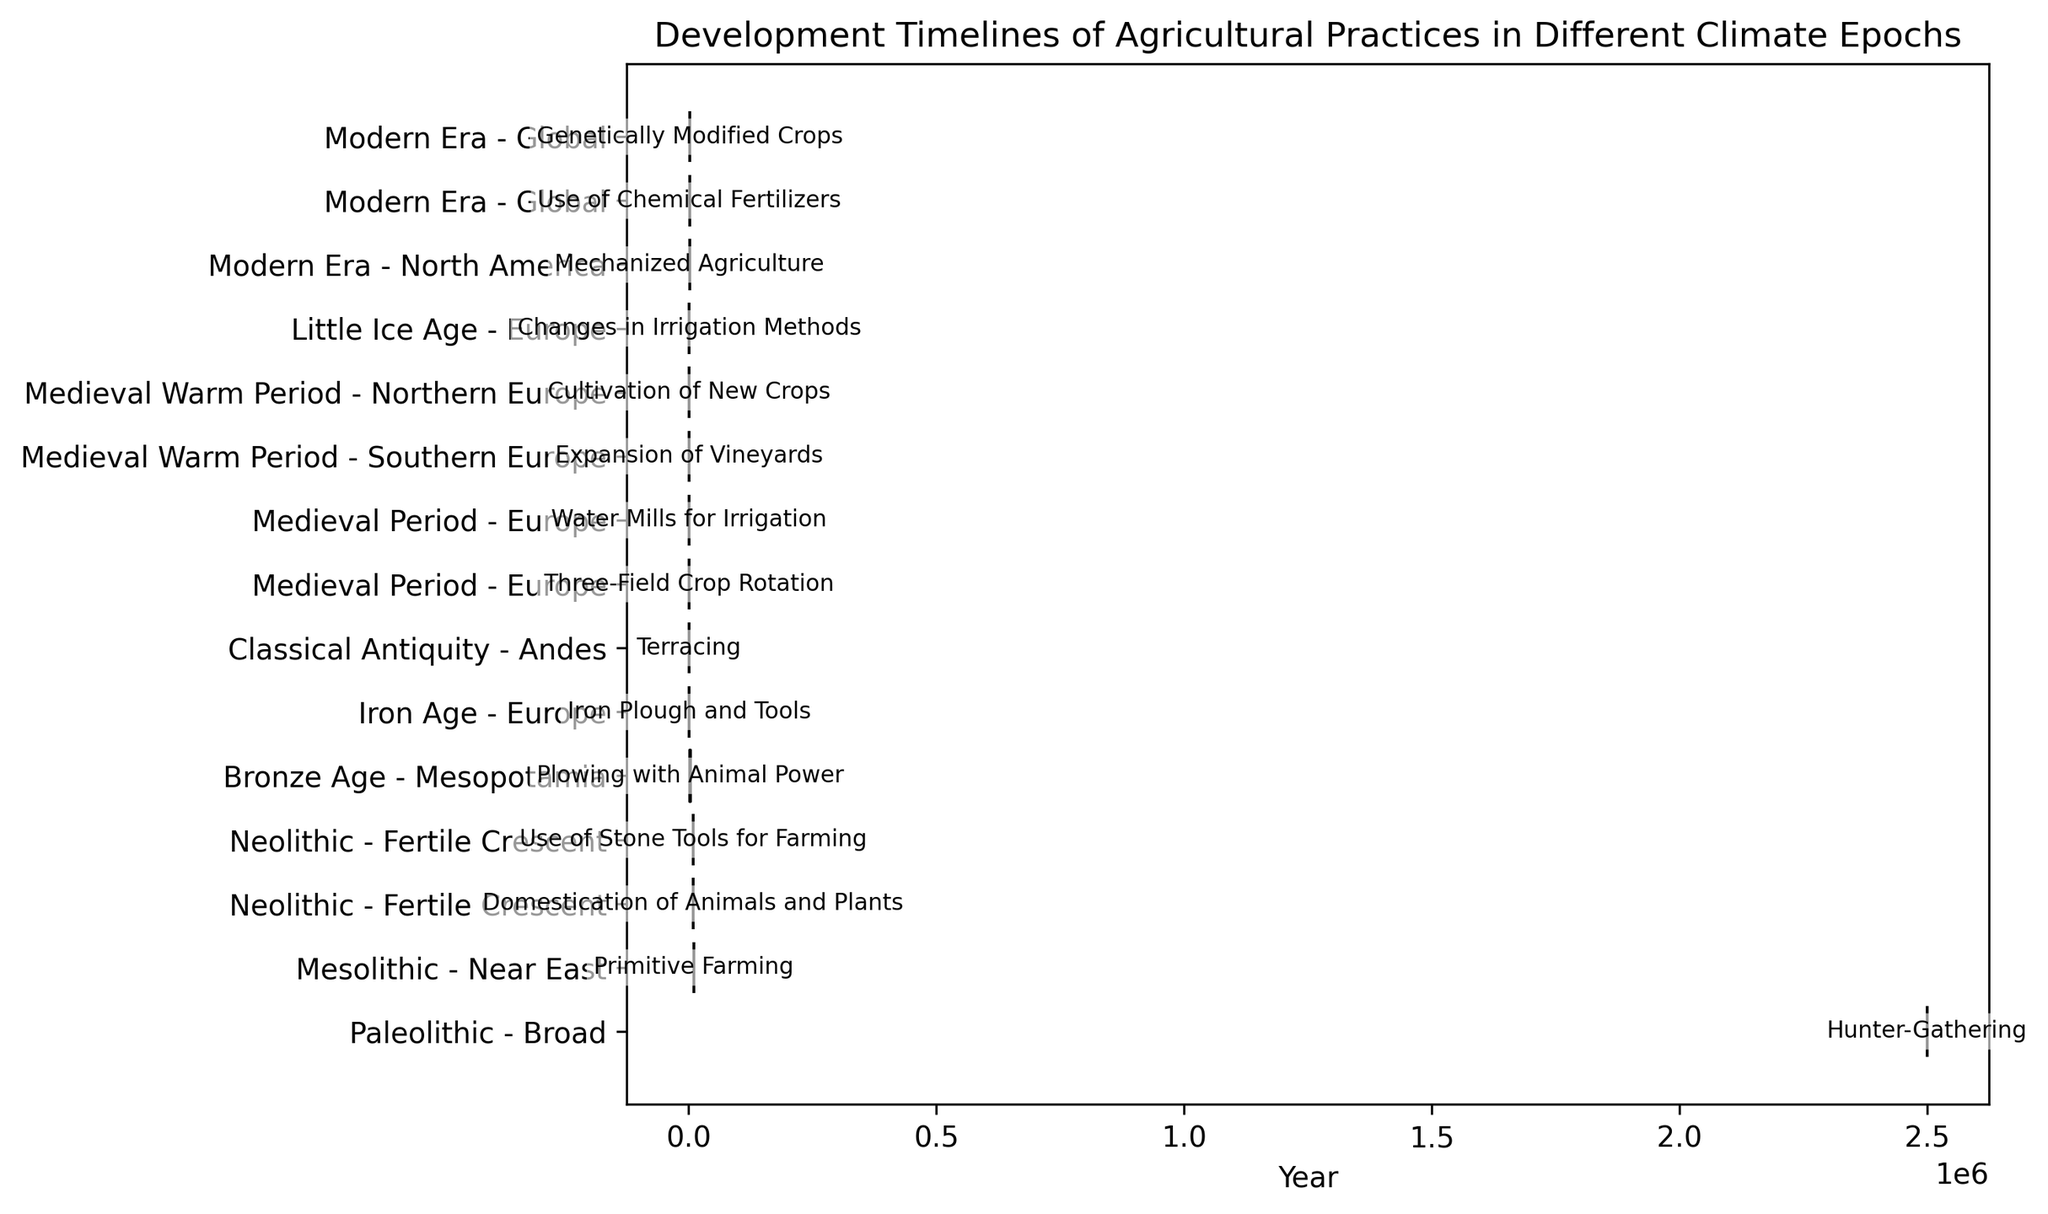Which epoch has the earliest development of agricultural practices? The practices are sorted by their start years, allowing us to identify the earliest. The Paleolithic epoch begins with Hunter-Gathering around 2,500,000 years ago.
Answer: Paleolithic What are the two agricultural practices developed in the Neolithic epoch and where were they developed? The figure shows Neolithic epoch practices such as Domestication of Animals and Plants and Use of Stone Tools for Farming, both developed in the Fertile Crescent.
Answer: Domestication of Animals and Plants, Use of Stone Tools for Farming; Fertile Crescent How many agricultural practices emerged during the Medieval Period? Count the number of practices listed under the Medieval Period. The figure shows Three-Field Crop Rotation, Water Mills for Irrigation, Expansion of Vineyards, and Cultivation of New Crops.
Answer: 4 Which epoch introduced the highest number of new agricultural practices? Compare each epoch to see which has the most entries. The Medieval Period lists four practices, the highest compared to other epochs.
Answer: Medieval Period Which regions introduced major agricultural advancements during the Mesolithic and Neolithic epochs? Look at the "Developed Region" for practices in Mesolithic and Neolithic epochs. The Near East and Fertile Crescent show advancements.
Answer: Near East; Fertile Crescent Which practice marked the transition from the Bronze Age to the Iron Age, and which regions were involved? Identify practices at the end of the Bronze Age and the start of the Iron Age. Plowing with Animal Power in Mesopotamia ends the Bronze Age, and Iron Plough and Tools start the Iron Age in Europe.
Answer: Plowing with Animal Power in Mesopotamia; Iron Plough and Tools in Europe Between what years did the transition from Medieval Period to the Medieval Warm Period occur according to the agricultural practices? The practices date from 800 to 1200. The last practice in the Medieval Period is at 1000, and the first in the Medieval Warm Period is at 1100, placing the transition around these years.
Answer: 1000-1100 Which agricultural practice in the Modern Era started earliest, and in which region did it develop? The first practice in the Modern Era is Mechanized Agriculture starting in 1800, developed in North America.
Answer: Mechanized Agriculture; North America How many agricultural practices were developed globally during the Modern Era and what are their start years? Two practices were global: Use of Chemical Fertilizers and Genetically Modified Crops. These practices started in 1900 and 1990, respectively.
Answer: 2; 1900 and 1990 